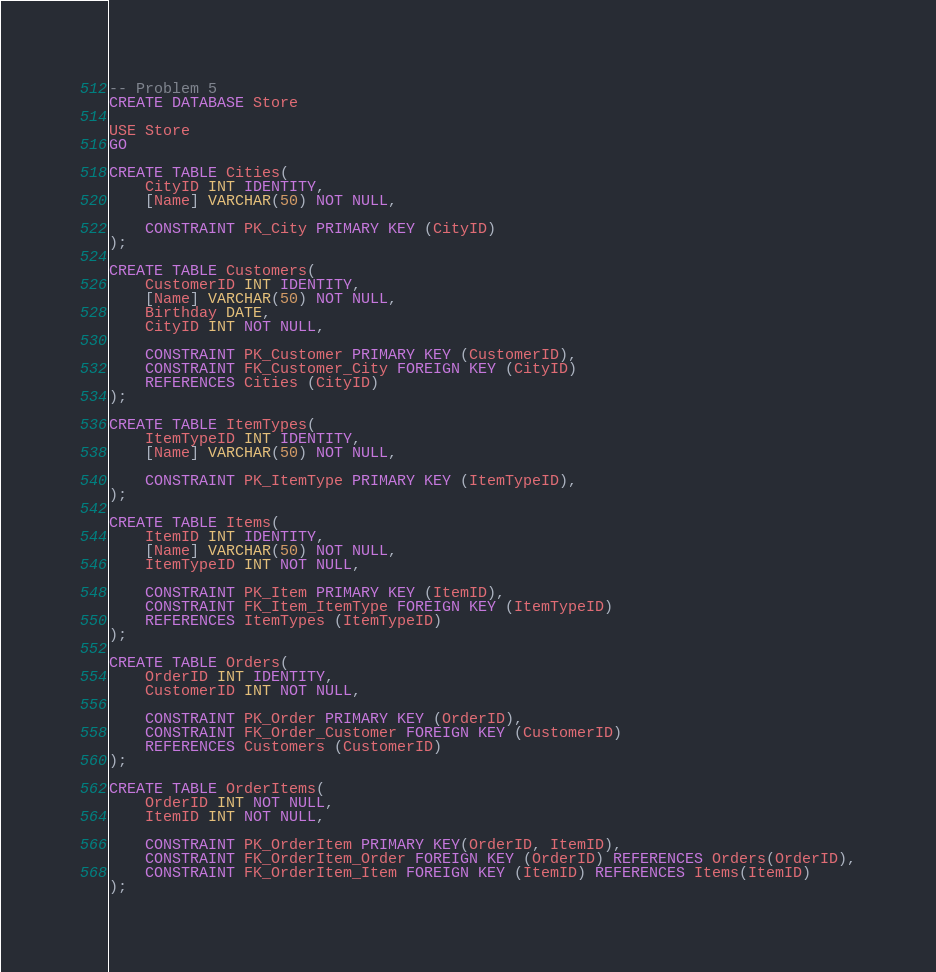Convert code to text. <code><loc_0><loc_0><loc_500><loc_500><_SQL_>-- Problem 5
CREATE DATABASE Store

USE Store
GO

CREATE TABLE Cities(
	CityID INT IDENTITY,
	[Name] VARCHAR(50) NOT NULL,

	CONSTRAINT PK_City PRIMARY KEY (CityID)
);

CREATE TABLE Customers(
	CustomerID INT IDENTITY,
	[Name] VARCHAR(50) NOT NULL,
	Birthday DATE,
	CityID INT NOT NULL,

	CONSTRAINT PK_Customer PRIMARY KEY (CustomerID),
	CONSTRAINT FK_Customer_City FOREIGN KEY (CityID)
	REFERENCES Cities (CityID)
);

CREATE TABLE ItemTypes(
	ItemTypeID INT IDENTITY,
	[Name] VARCHAR(50) NOT NULL,

	CONSTRAINT PK_ItemType PRIMARY KEY (ItemTypeID),
);

CREATE TABLE Items(
	ItemID INT IDENTITY,
	[Name] VARCHAR(50) NOT NULL,
	ItemTypeID INT NOT NULL,

	CONSTRAINT PK_Item PRIMARY KEY (ItemID),
	CONSTRAINT FK_Item_ItemType FOREIGN KEY (ItemTypeID)
	REFERENCES ItemTypes (ItemTypeID)
);

CREATE TABLE Orders(
	OrderID INT IDENTITY,
	CustomerID INT NOT NULL,

	CONSTRAINT PK_Order PRIMARY KEY (OrderID),
	CONSTRAINT FK_Order_Customer FOREIGN KEY (CustomerID)
	REFERENCES Customers (CustomerID)
);

CREATE TABLE OrderItems(
	OrderID INT NOT NULL,
	ItemID INT NOT NULL,

	CONSTRAINT PK_OrderItem PRIMARY KEY(OrderID, ItemID),
	CONSTRAINT FK_OrderItem_Order FOREIGN KEY (OrderID) REFERENCES Orders(OrderID),
	CONSTRAINT FK_OrderItem_Item FOREIGN KEY (ItemID) REFERENCES Items(ItemID)
);</code> 